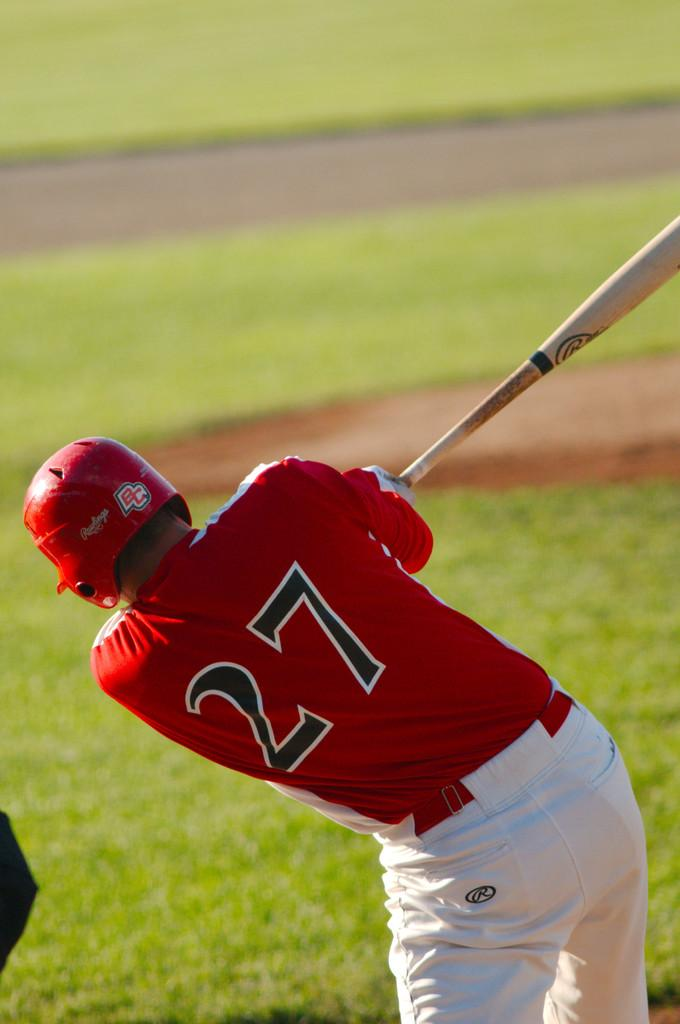What is the main subject of the image? There is a person in the image. What type of clothing is the person wearing? The person is wearing a t-shirt. What protective gear is the person wearing on their head? The person is wearing a helmet on their head. What object is the person holding in their hand? The person is holding a bat in their hand. In which direction is the person facing? The person is standing facing towards the back side. What type of environment can be seen in the background of the image? There is grass visible in the background of the image. What type of linen is draped over the person's shoulders in the image? There is no linen draped over the person's shoulders in the image. What type of ball is the person about to throw in the image? The person is holding a bat, not a ball, in their hand. 